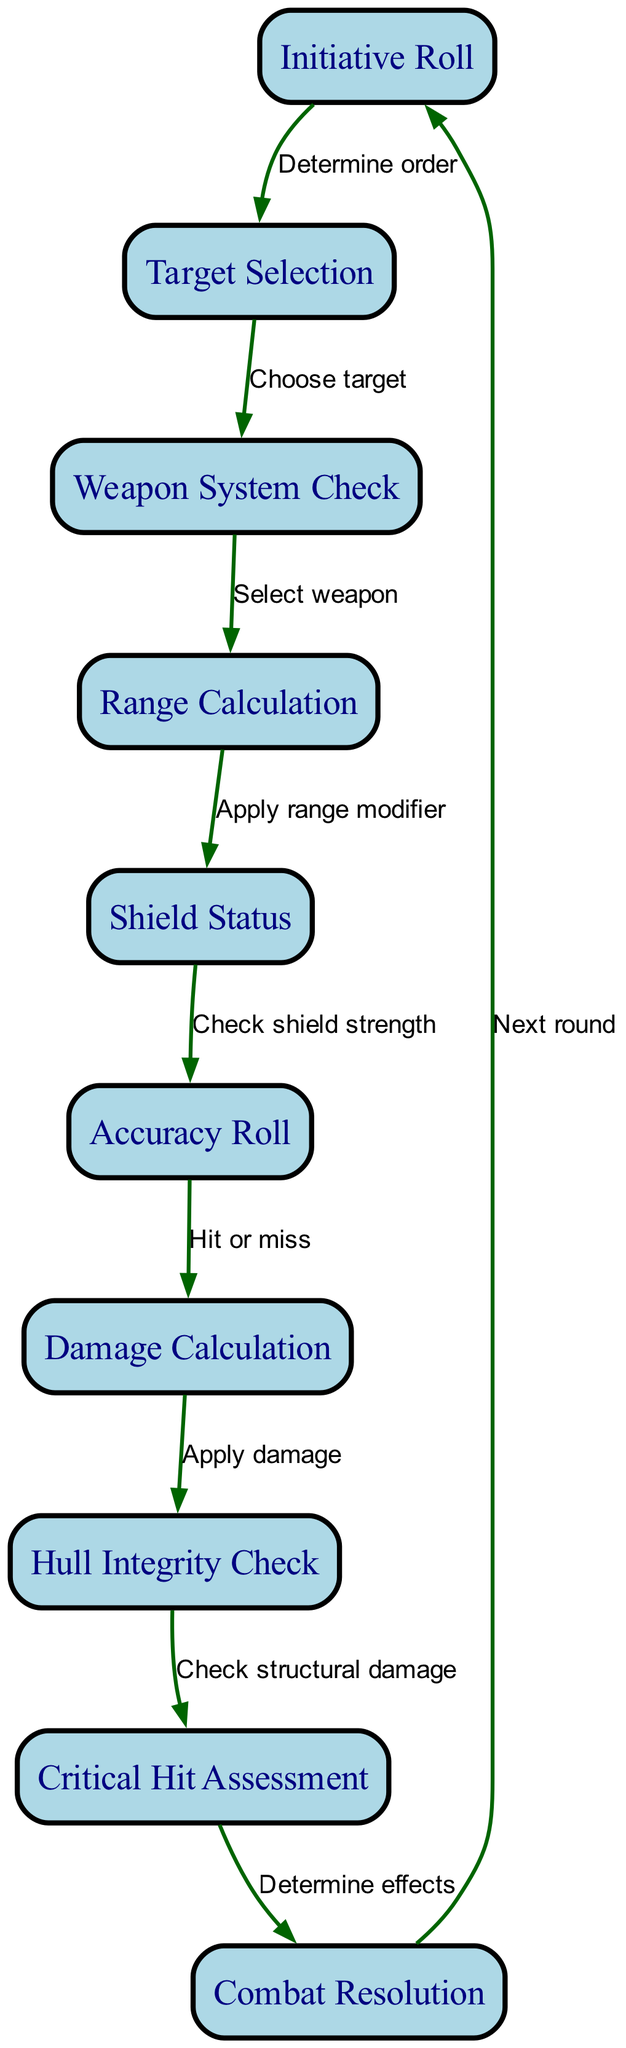What is the first step in the combat resolution sequence? The first step is labeled "Initiative Roll," which indicates it is the initial process in the sequence.
Answer: Initiative Roll How many nodes are present in the diagram? The diagram contains ten distinct nodes, as counted from the provided list.
Answer: 10 What happens after "Target Selection"? After "Target Selection," the next step is "Weapon System Check," which indicates the process of selecting the appropriate weapon for the chosen target.
Answer: Weapon System Check What is checked before the accuracy roll? Before the accuracy roll, "Shield Status" is checked to assess the shield's strength, which influences the accuracy outcome.
Answer: Shield Status Which node follows "Critical Hit Assessment"? The node that follows "Critical Hit Assessment" is "Combat Resolution." This step determines the overall effects of the combat engagement.
Answer: Combat Resolution What is the relationship between "Damage Calculation" and "Hull Integrity Check"? "Damage Calculation" precedes "Hull Integrity Check," meaning that the damage inflicted must be assessed before checking the integrity of the ship's hull.
Answer: Apply damage How many edges are there in the diagram? There are nine edges in the diagram, as each edge represents a directional flow from one process to another in the combat sequence.
Answer: 9 If the shield is strong, which node is directly affected? A strong shield directly affects the "Accuracy Roll," as it modifies the hit or miss outcome based on shield strength.
Answer: Accuracy Roll What is the purpose of the "Range Calculation" node? The purpose of the "Range Calculation" node is to apply a range modifier, influencing the subsequent "Shield Status" check and the overall combat effectiveness.
Answer: Apply range modifier 